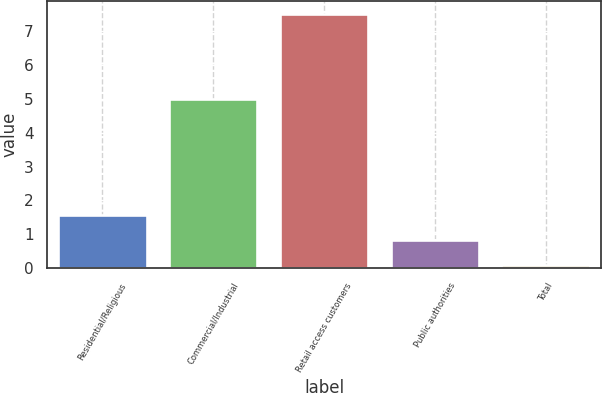<chart> <loc_0><loc_0><loc_500><loc_500><bar_chart><fcel>Residential/Religious<fcel>Commercial/Industrial<fcel>Retail access customers<fcel>Public authorities<fcel>Total<nl><fcel>1.58<fcel>5<fcel>7.5<fcel>0.84<fcel>0.1<nl></chart> 